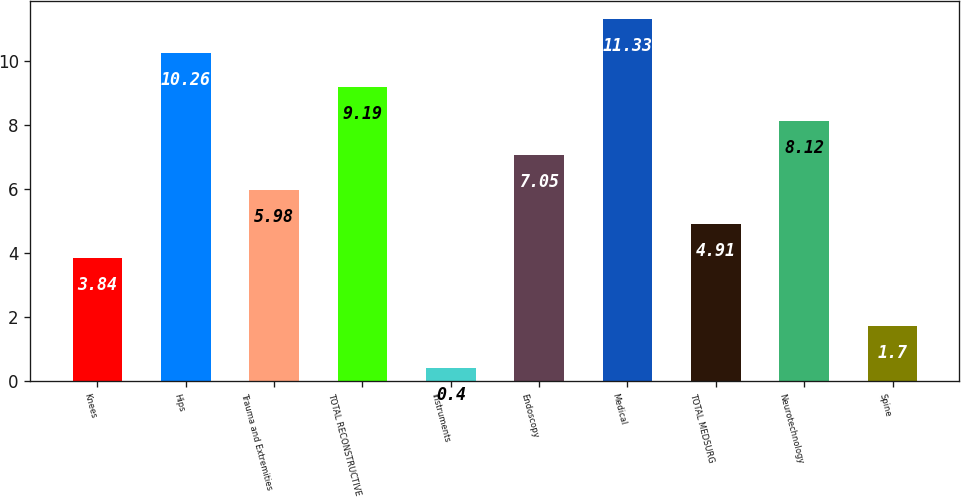Convert chart. <chart><loc_0><loc_0><loc_500><loc_500><bar_chart><fcel>Knees<fcel>Hips<fcel>Trauma and Extremities<fcel>TOTAL RECONSTRUCTIVE<fcel>Instruments<fcel>Endoscopy<fcel>Medical<fcel>TOTAL MEDSURG<fcel>Neurotechnology<fcel>Spine<nl><fcel>3.84<fcel>10.26<fcel>5.98<fcel>9.19<fcel>0.4<fcel>7.05<fcel>11.33<fcel>4.91<fcel>8.12<fcel>1.7<nl></chart> 